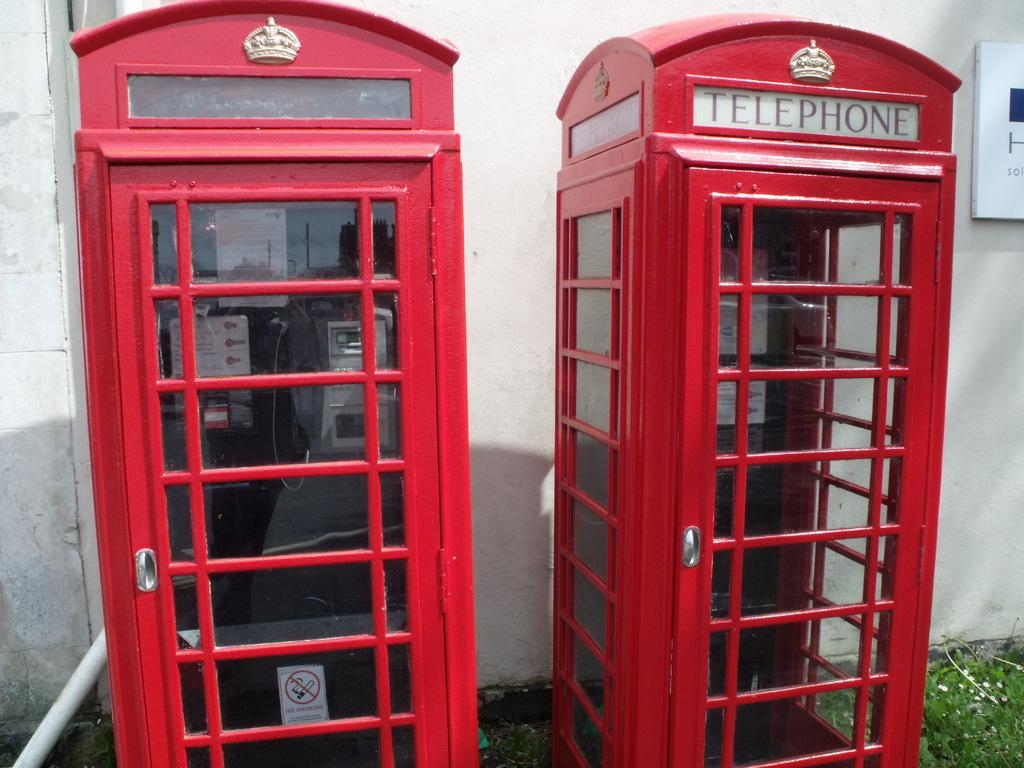<image>
Provide a brief description of the given image. A red box with the word Telephone on it. 